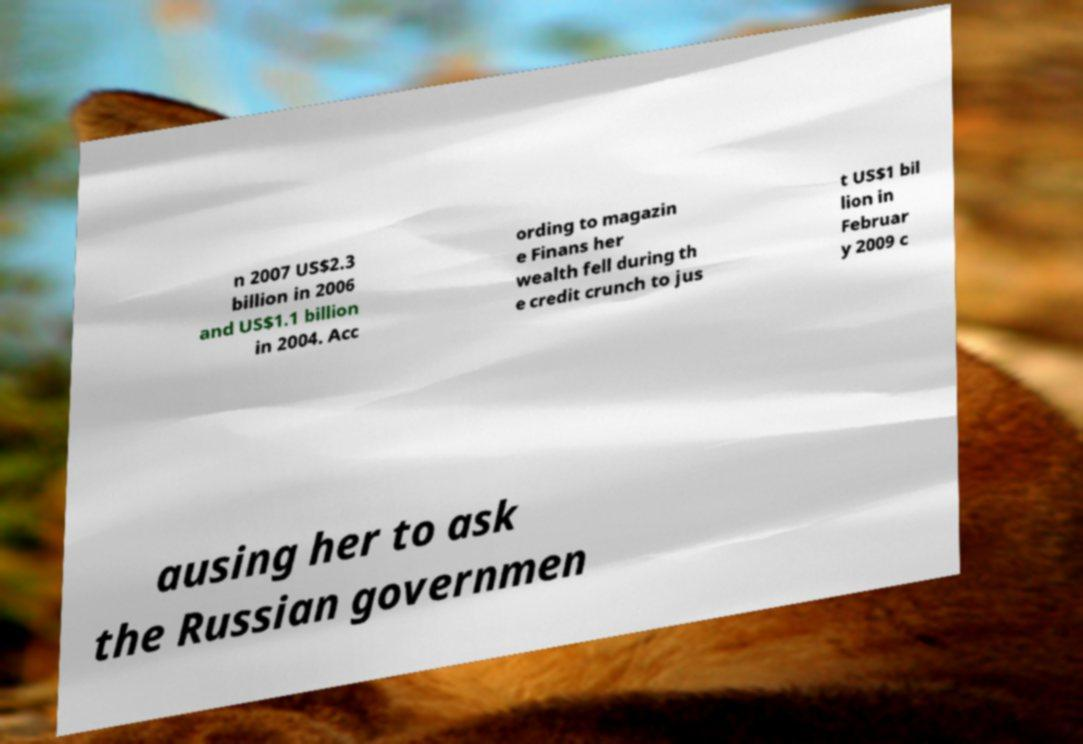There's text embedded in this image that I need extracted. Can you transcribe it verbatim? n 2007 US$2.3 billion in 2006 and US$1.1 billion in 2004. Acc ording to magazin e Finans her wealth fell during th e credit crunch to jus t US$1 bil lion in Februar y 2009 c ausing her to ask the Russian governmen 